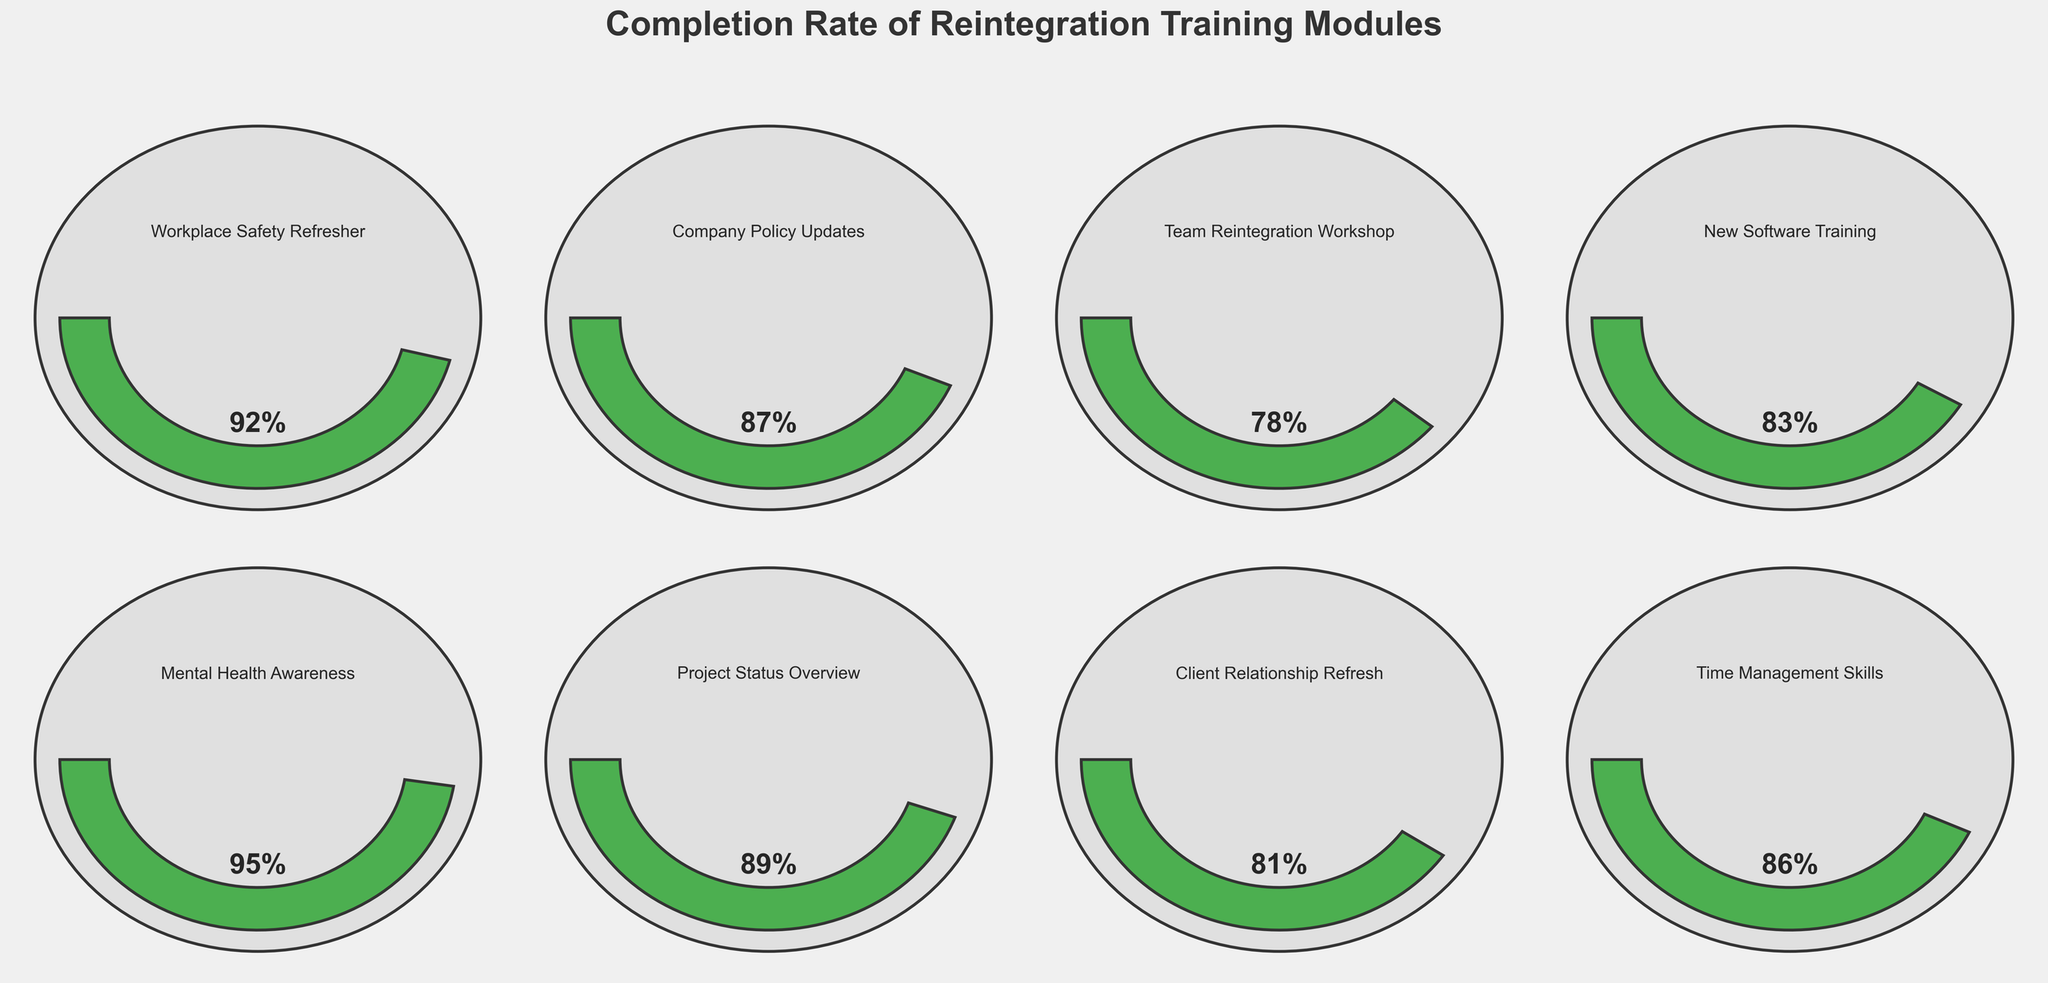What's the title of the figure? The title is usually placed prominently at the top of a figure. In this case, the title "Completion Rate of Reintegration Training Modules" is clearly displayed at the top of the plot.
Answer: Completion Rate of Reintegration Training Modules How many training modules are displayed in the figure? By counting the number of gauge charts shown in the figure, you can identify that there are 8 different training modules. Each gauge represents one module.
Answer: 8 Which training module has the highest completion rate? By looking at the gauge charts, the Mental Health Awareness module shows the highest completion rate with the gauge filled the most and displaying 95%.
Answer: Mental Health Awareness Which training module has the lowest completion rate? By examining the gauges, the Team Reintegration Workshop has the lowest completion rate as the gauge is less filled compared to others and shows 78%.
Answer: Team Reintegration Workshop What's the completion rate for the Company Policy Updates module? Locate the gauge chart for the Company Policy Updates module and read the value displayed on the gauge. The completion rate shown is 87%.
Answer: 87% Is the completion rate for New Software Training greater than the Completion Rate of Time Management Skills? Compare the two gauges for New Software Training and Time Management Skills. New Software Training has a completion rate of 83%, and Time Management Skills has 86%.
Answer: No What is the average completion rate of the training modules? To calculate the average, sum the completion rates of all modules: 0.92 + 0.87 + 0.78 + 0.83 + 0.95 + 0.89 + 0.81 + 0.86 = 6.91. Then divide by the number of modules: 6.91 / 8 = 0.86375, or approximately 86.38%.
Answer: 86.38% How many modules have a completion rate higher than 85%? By checking each gauge chart and counting how many have a completion rate above 85%, there are 5: Workplace Safety Refresher (92%), Company Policy Updates (87%), New Software Training (83%), Mental Health Awareness (95%), and Time Management Skills (86%).
Answer: 5 Is the completion rate of the Client Relationship Refresh Module less than the completion rate of the Project Status Overview? Look at the gauges for both modules, where Client Relationship Refresh has a completion rate of 81%, and Project Status Overview has 89%. Since 81% < 89%, the Client Relationship Refresh completion rate is less.
Answer: Yes What is the median completion rate of the training modules? To find the median, list the completion rates in ascending order: 0.78, 0.81, 0.83, 0.86, 0.87, 0.89, 0.92, 0.95. The median is the average of the 4th and 5th values in this sorted list: (0.86 + 0.87) / 2 = 0.865, or 86.5%
Answer: 86.5% 